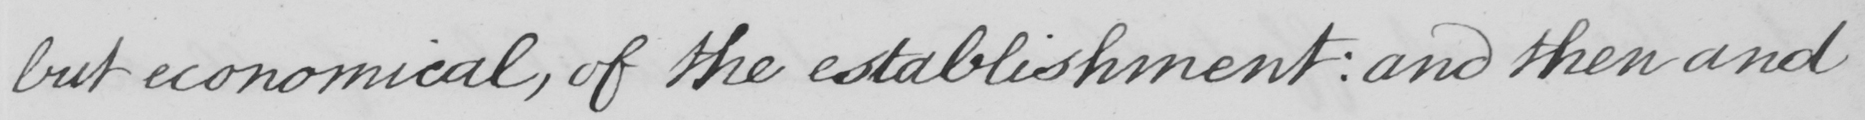What text is written in this handwritten line? but economical , of the establishment :  and then and 